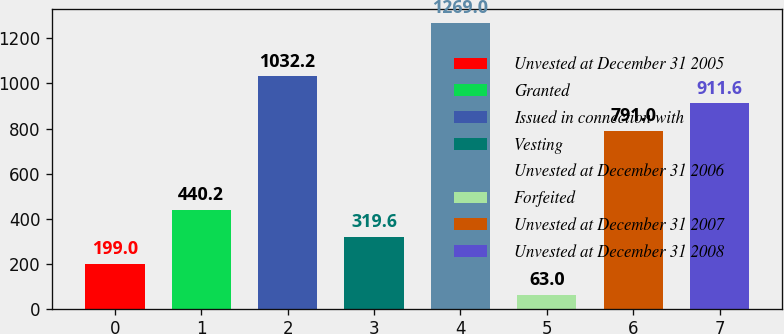Convert chart to OTSL. <chart><loc_0><loc_0><loc_500><loc_500><bar_chart><fcel>Unvested at December 31 2005<fcel>Granted<fcel>Issued in connection with<fcel>Vesting<fcel>Unvested at December 31 2006<fcel>Forfeited<fcel>Unvested at December 31 2007<fcel>Unvested at December 31 2008<nl><fcel>199<fcel>440.2<fcel>1032.2<fcel>319.6<fcel>1269<fcel>63<fcel>791<fcel>911.6<nl></chart> 